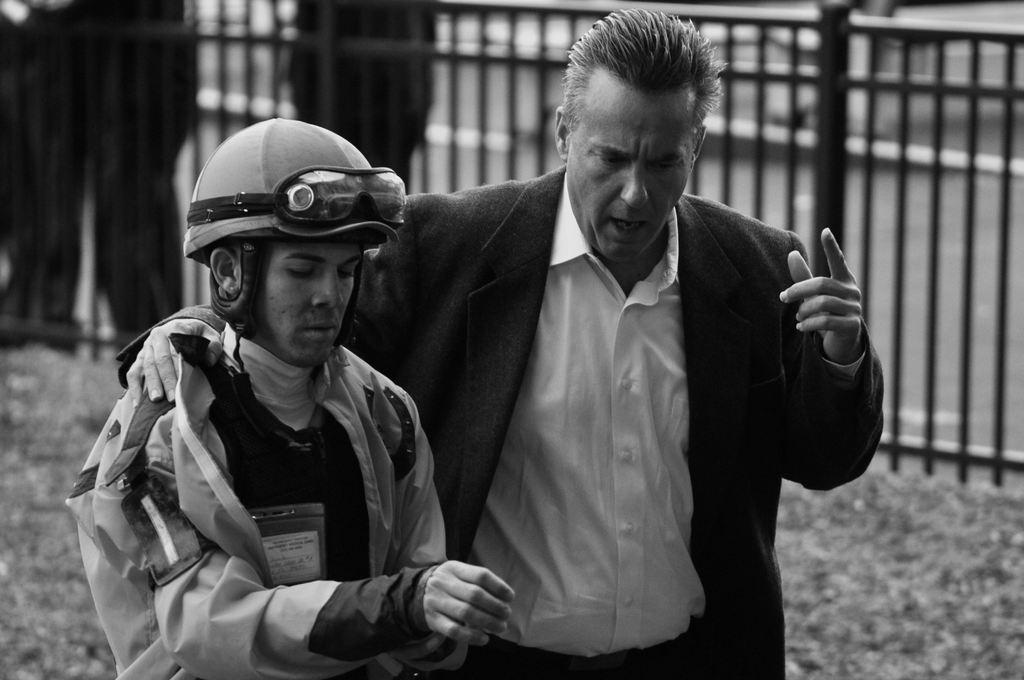How would you summarize this image in a sentence or two? This picture is in black and white. In the center, there is man holding another man. One of the person towards the right, he is blazer and a white shirt. Towards the left, there is another man wearing a uniform and a helmet. Behind them, there is a fence. 